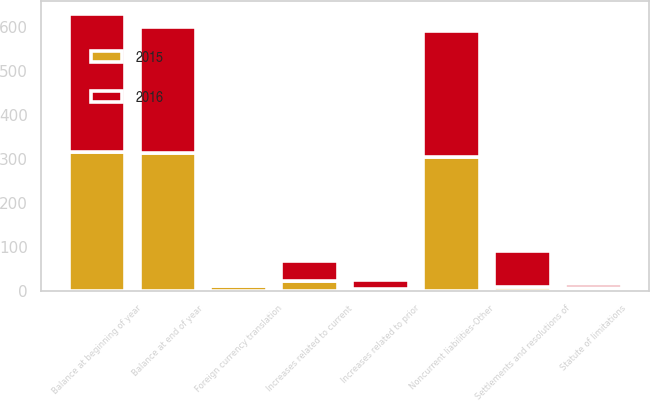<chart> <loc_0><loc_0><loc_500><loc_500><stacked_bar_chart><ecel><fcel>Balance at beginning of year<fcel>Increases related to current<fcel>Increases related to prior<fcel>Settlements and resolutions of<fcel>Statute of limitations<fcel>Foreign currency translation<fcel>Balance at end of year<fcel>Noncurrent liabilities-Other<nl><fcel>2016<fcel>313<fcel>47<fcel>22<fcel>82<fcel>9<fcel>4<fcel>287<fcel>287<nl><fcel>2015<fcel>315<fcel>21<fcel>3<fcel>9<fcel>6<fcel>11<fcel>313<fcel>304<nl></chart> 